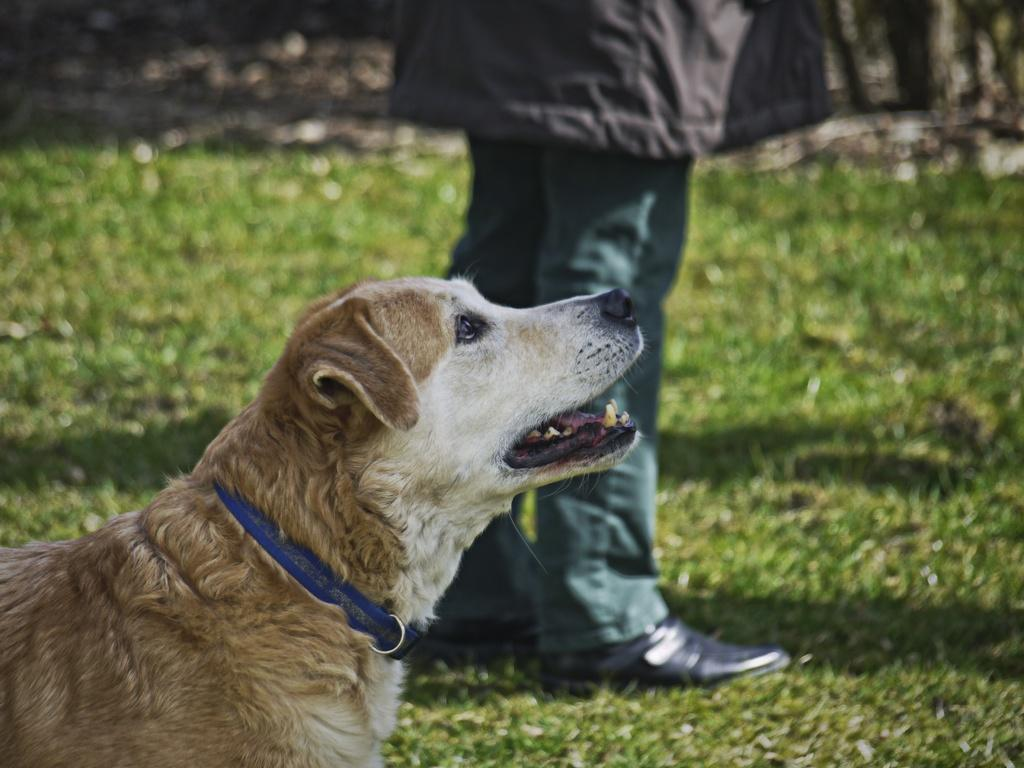What type of animal is in the image? There is a dog in the image. What colors can be seen on the dog? The dog is white and brown in color. What is around the dog's neck? The dog has a blue belt around its neck. Who else is in the image besides the dog? There is a human in the image. What type of ground is visible in the image? There is grass on the ground in the image. What type of servant is the dog performing in the image? There is no indication in the image that the dog is serving as a servant or performing any specific task. 